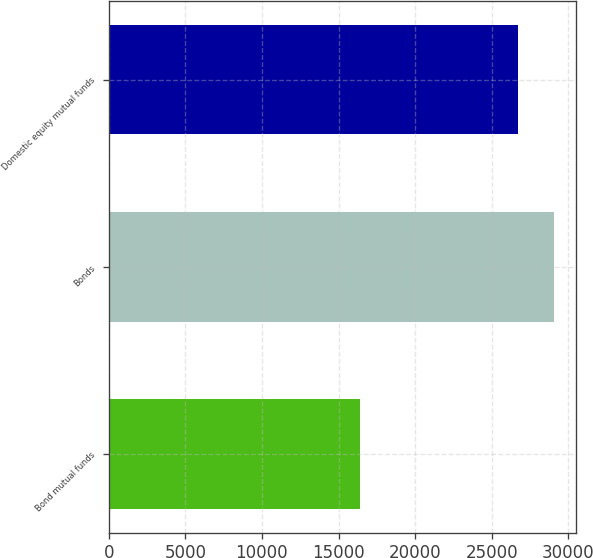Convert chart to OTSL. <chart><loc_0><loc_0><loc_500><loc_500><bar_chart><fcel>Bond mutual funds<fcel>Bonds<fcel>Domestic equity mutual funds<nl><fcel>16391<fcel>29074<fcel>26692<nl></chart> 